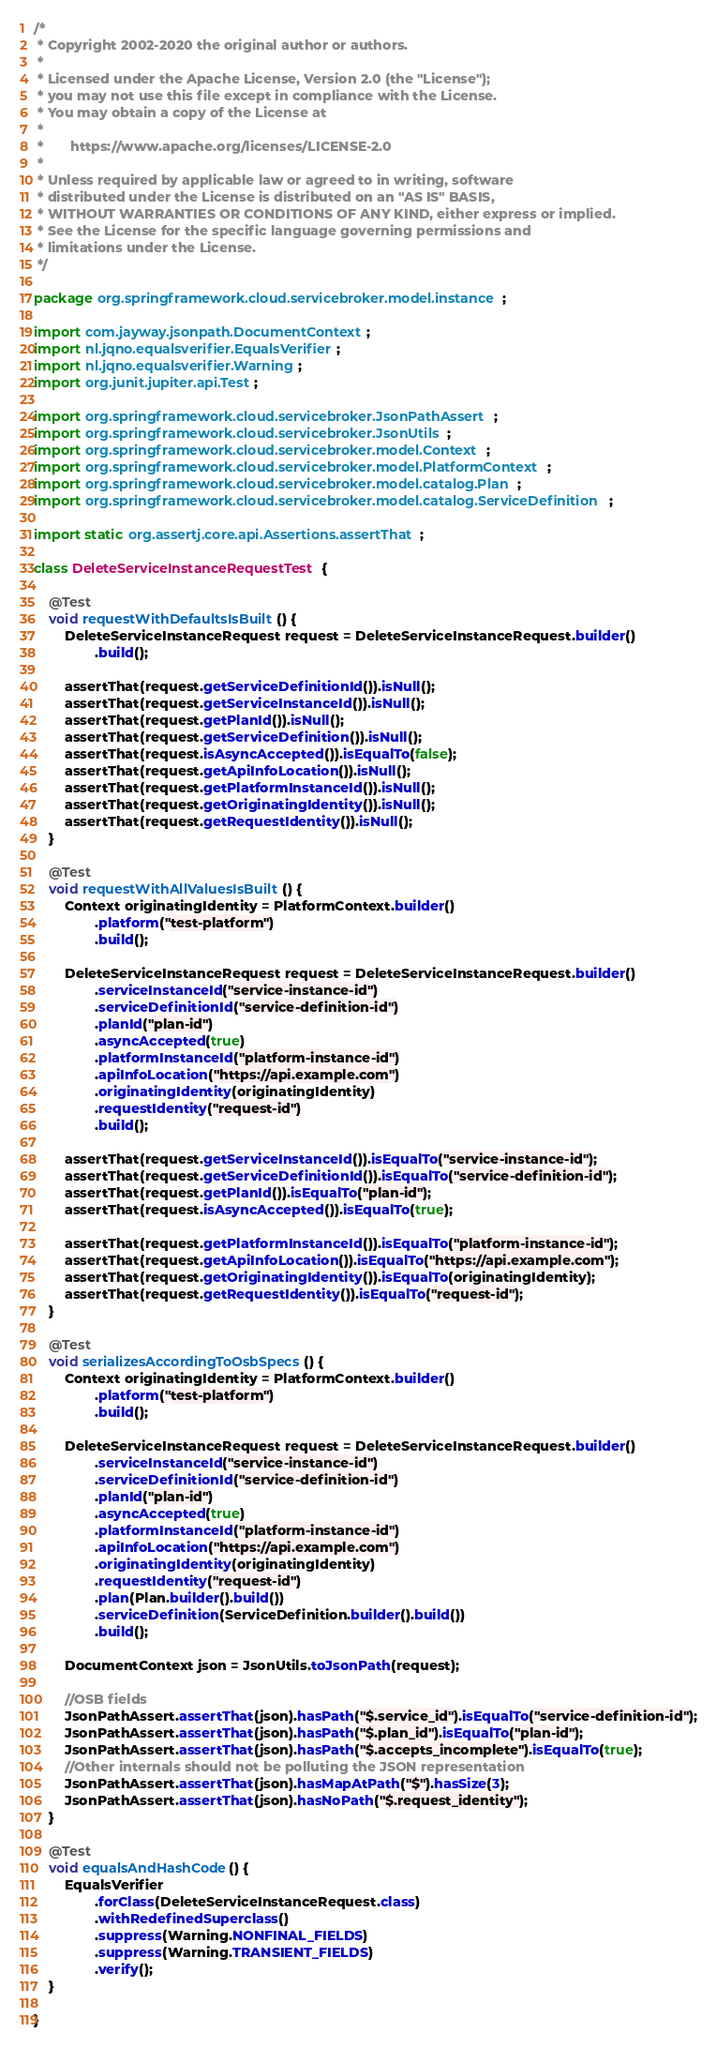Convert code to text. <code><loc_0><loc_0><loc_500><loc_500><_Java_>/*
 * Copyright 2002-2020 the original author or authors.
 *
 * Licensed under the Apache License, Version 2.0 (the "License");
 * you may not use this file except in compliance with the License.
 * You may obtain a copy of the License at
 *
 *       https://www.apache.org/licenses/LICENSE-2.0
 *
 * Unless required by applicable law or agreed to in writing, software
 * distributed under the License is distributed on an "AS IS" BASIS,
 * WITHOUT WARRANTIES OR CONDITIONS OF ANY KIND, either express or implied.
 * See the License for the specific language governing permissions and
 * limitations under the License.
 */

package org.springframework.cloud.servicebroker.model.instance;

import com.jayway.jsonpath.DocumentContext;
import nl.jqno.equalsverifier.EqualsVerifier;
import nl.jqno.equalsverifier.Warning;
import org.junit.jupiter.api.Test;

import org.springframework.cloud.servicebroker.JsonPathAssert;
import org.springframework.cloud.servicebroker.JsonUtils;
import org.springframework.cloud.servicebroker.model.Context;
import org.springframework.cloud.servicebroker.model.PlatformContext;
import org.springframework.cloud.servicebroker.model.catalog.Plan;
import org.springframework.cloud.servicebroker.model.catalog.ServiceDefinition;

import static org.assertj.core.api.Assertions.assertThat;

class DeleteServiceInstanceRequestTest {

	@Test
	void requestWithDefaultsIsBuilt() {
		DeleteServiceInstanceRequest request = DeleteServiceInstanceRequest.builder()
				.build();

		assertThat(request.getServiceDefinitionId()).isNull();
		assertThat(request.getServiceInstanceId()).isNull();
		assertThat(request.getPlanId()).isNull();
		assertThat(request.getServiceDefinition()).isNull();
		assertThat(request.isAsyncAccepted()).isEqualTo(false);
		assertThat(request.getApiInfoLocation()).isNull();
		assertThat(request.getPlatformInstanceId()).isNull();
		assertThat(request.getOriginatingIdentity()).isNull();
		assertThat(request.getRequestIdentity()).isNull();
	}

	@Test
	void requestWithAllValuesIsBuilt() {
		Context originatingIdentity = PlatformContext.builder()
				.platform("test-platform")
				.build();

		DeleteServiceInstanceRequest request = DeleteServiceInstanceRequest.builder()
				.serviceInstanceId("service-instance-id")
				.serviceDefinitionId("service-definition-id")
				.planId("plan-id")
				.asyncAccepted(true)
				.platformInstanceId("platform-instance-id")
				.apiInfoLocation("https://api.example.com")
				.originatingIdentity(originatingIdentity)
				.requestIdentity("request-id")
				.build();

		assertThat(request.getServiceInstanceId()).isEqualTo("service-instance-id");
		assertThat(request.getServiceDefinitionId()).isEqualTo("service-definition-id");
		assertThat(request.getPlanId()).isEqualTo("plan-id");
		assertThat(request.isAsyncAccepted()).isEqualTo(true);

		assertThat(request.getPlatformInstanceId()).isEqualTo("platform-instance-id");
		assertThat(request.getApiInfoLocation()).isEqualTo("https://api.example.com");
		assertThat(request.getOriginatingIdentity()).isEqualTo(originatingIdentity);
		assertThat(request.getRequestIdentity()).isEqualTo("request-id");
	}

	@Test
	void serializesAccordingToOsbSpecs() {
		Context originatingIdentity = PlatformContext.builder()
				.platform("test-platform")
				.build();

		DeleteServiceInstanceRequest request = DeleteServiceInstanceRequest.builder()
				.serviceInstanceId("service-instance-id")
				.serviceDefinitionId("service-definition-id")
				.planId("plan-id")
				.asyncAccepted(true)
				.platformInstanceId("platform-instance-id")
				.apiInfoLocation("https://api.example.com")
				.originatingIdentity(originatingIdentity)
				.requestIdentity("request-id")
				.plan(Plan.builder().build())
				.serviceDefinition(ServiceDefinition.builder().build())
				.build();

		DocumentContext json = JsonUtils.toJsonPath(request);

		//OSB fields
		JsonPathAssert.assertThat(json).hasPath("$.service_id").isEqualTo("service-definition-id");
		JsonPathAssert.assertThat(json).hasPath("$.plan_id").isEqualTo("plan-id");
		JsonPathAssert.assertThat(json).hasPath("$.accepts_incomplete").isEqualTo(true);
		//Other internals should not be polluting the JSON representation
		JsonPathAssert.assertThat(json).hasMapAtPath("$").hasSize(3);
		JsonPathAssert.assertThat(json).hasNoPath("$.request_identity");
	}

	@Test
	void equalsAndHashCode() {
		EqualsVerifier
				.forClass(DeleteServiceInstanceRequest.class)
				.withRedefinedSuperclass()
				.suppress(Warning.NONFINAL_FIELDS)
				.suppress(Warning.TRANSIENT_FIELDS)
				.verify();
	}

}
</code> 